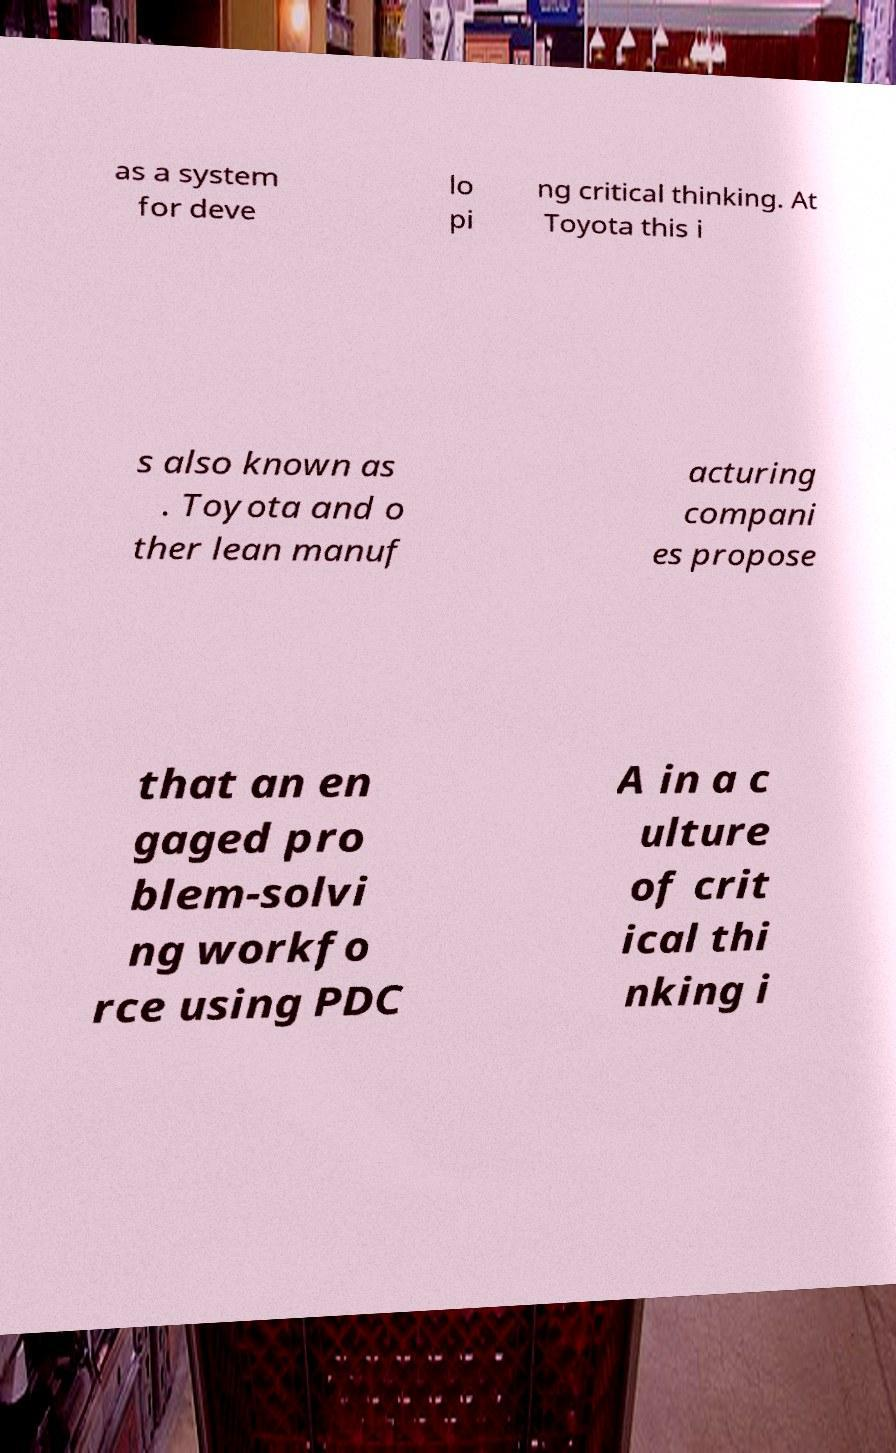Can you read and provide the text displayed in the image?This photo seems to have some interesting text. Can you extract and type it out for me? as a system for deve lo pi ng critical thinking. At Toyota this i s also known as . Toyota and o ther lean manuf acturing compani es propose that an en gaged pro blem-solvi ng workfo rce using PDC A in a c ulture of crit ical thi nking i 